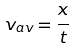Convert formula to latex. <formula><loc_0><loc_0><loc_500><loc_500>v _ { a v } = \frac { x } { t }</formula> 